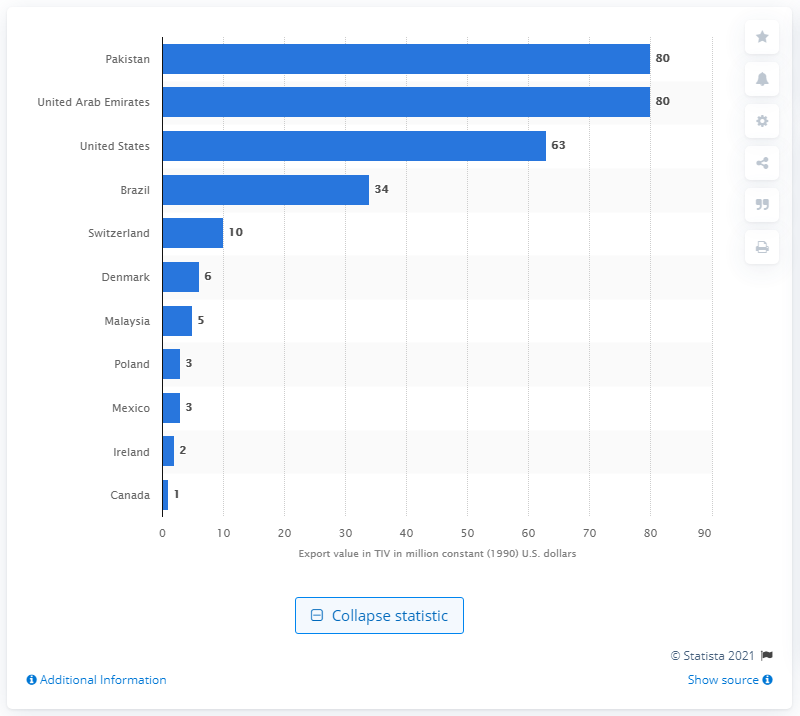Point out several critical features in this image. In 2020, the United States exported a total of 80 constant dollars worth of arms to Pakistan and the United Arab Emirates. 